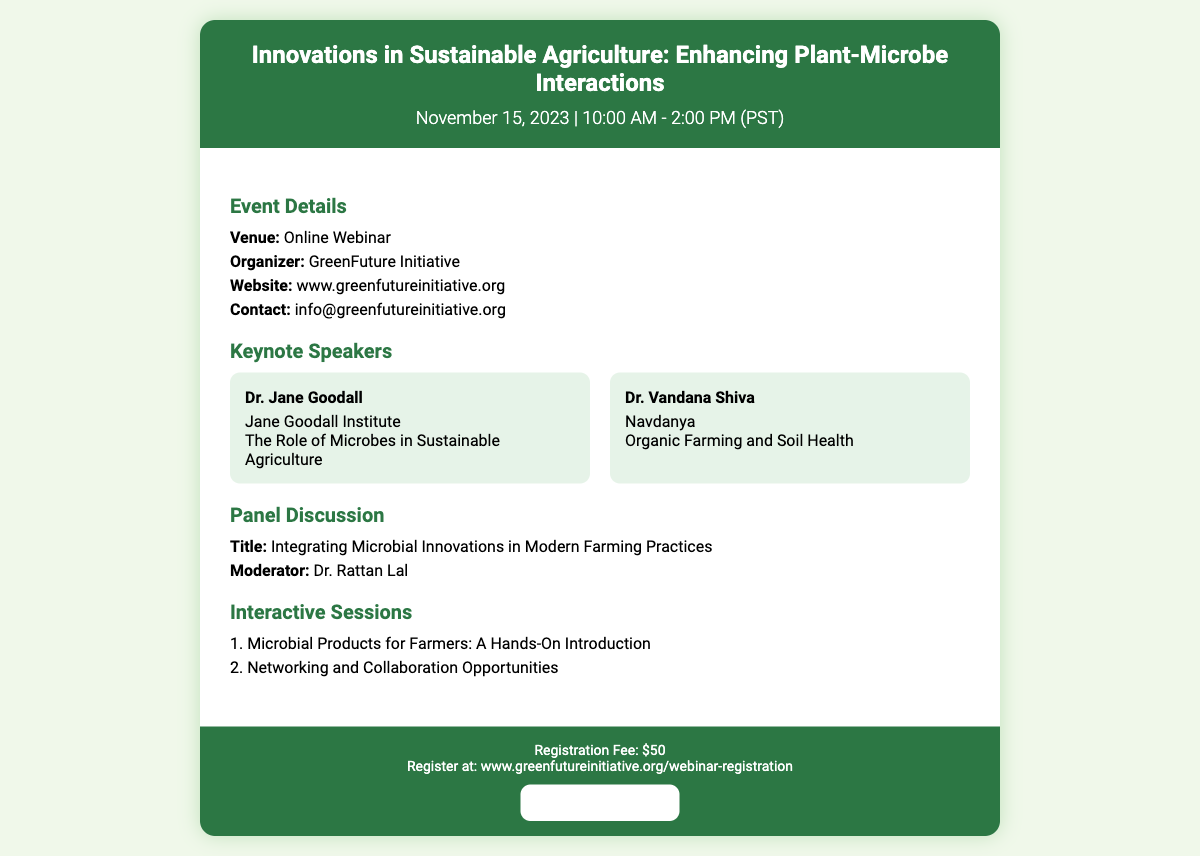what is the title of the webinar? The title of the webinar is stated in the ticket header.
Answer: Innovations in Sustainable Agriculture: Enhancing Plant-Microbe Interactions what is the registration fee for the webinar? The registration fee is mentioned in the ticket footer.
Answer: $50 who is moderating the panel discussion? The moderator's name is provided in the panel discussion section.
Answer: Dr. Rattan Lal what is the website for registration? The registration website is listed in the ticket footer.
Answer: www.greenfutureinitiative.org/webinar-registration who is one of the keynote speakers? The names of keynote speakers are listed in the key speaker section.
Answer: Dr. Jane Goodall what organization is hosting the webinar? The organizer’s name is provided in the event details.
Answer: GreenFuture Initiative how many interactive sessions are mentioned? The number of interactive sessions is detailed in the interactive sessions section.
Answer: 2 